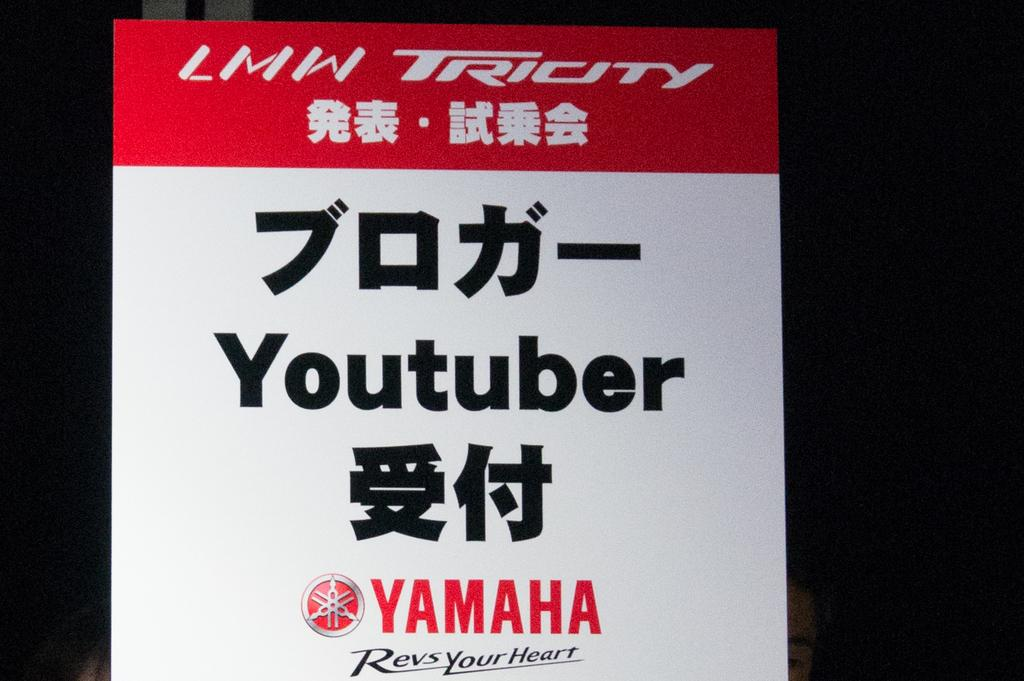<image>
Summarize the visual content of the image. A poster in red and white with the words Youtuber in the center and the brand Yamaha below 